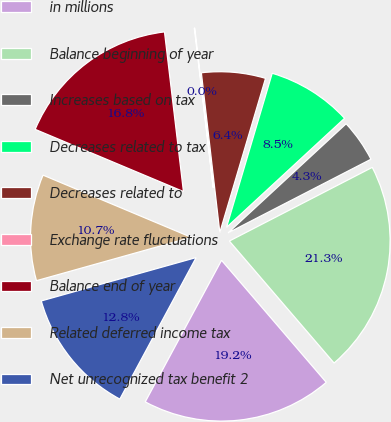Convert chart. <chart><loc_0><loc_0><loc_500><loc_500><pie_chart><fcel>in millions<fcel>Balance beginning of year<fcel>Increases based on tax<fcel>Decreases related to tax<fcel>Decreases related to<fcel>Exchange rate fluctuations<fcel>Balance end of year<fcel>Related deferred income tax<fcel>Net unrecognized tax benefit 2<nl><fcel>19.16%<fcel>21.29%<fcel>4.3%<fcel>8.54%<fcel>6.42%<fcel>0.05%<fcel>16.8%<fcel>10.67%<fcel>12.79%<nl></chart> 